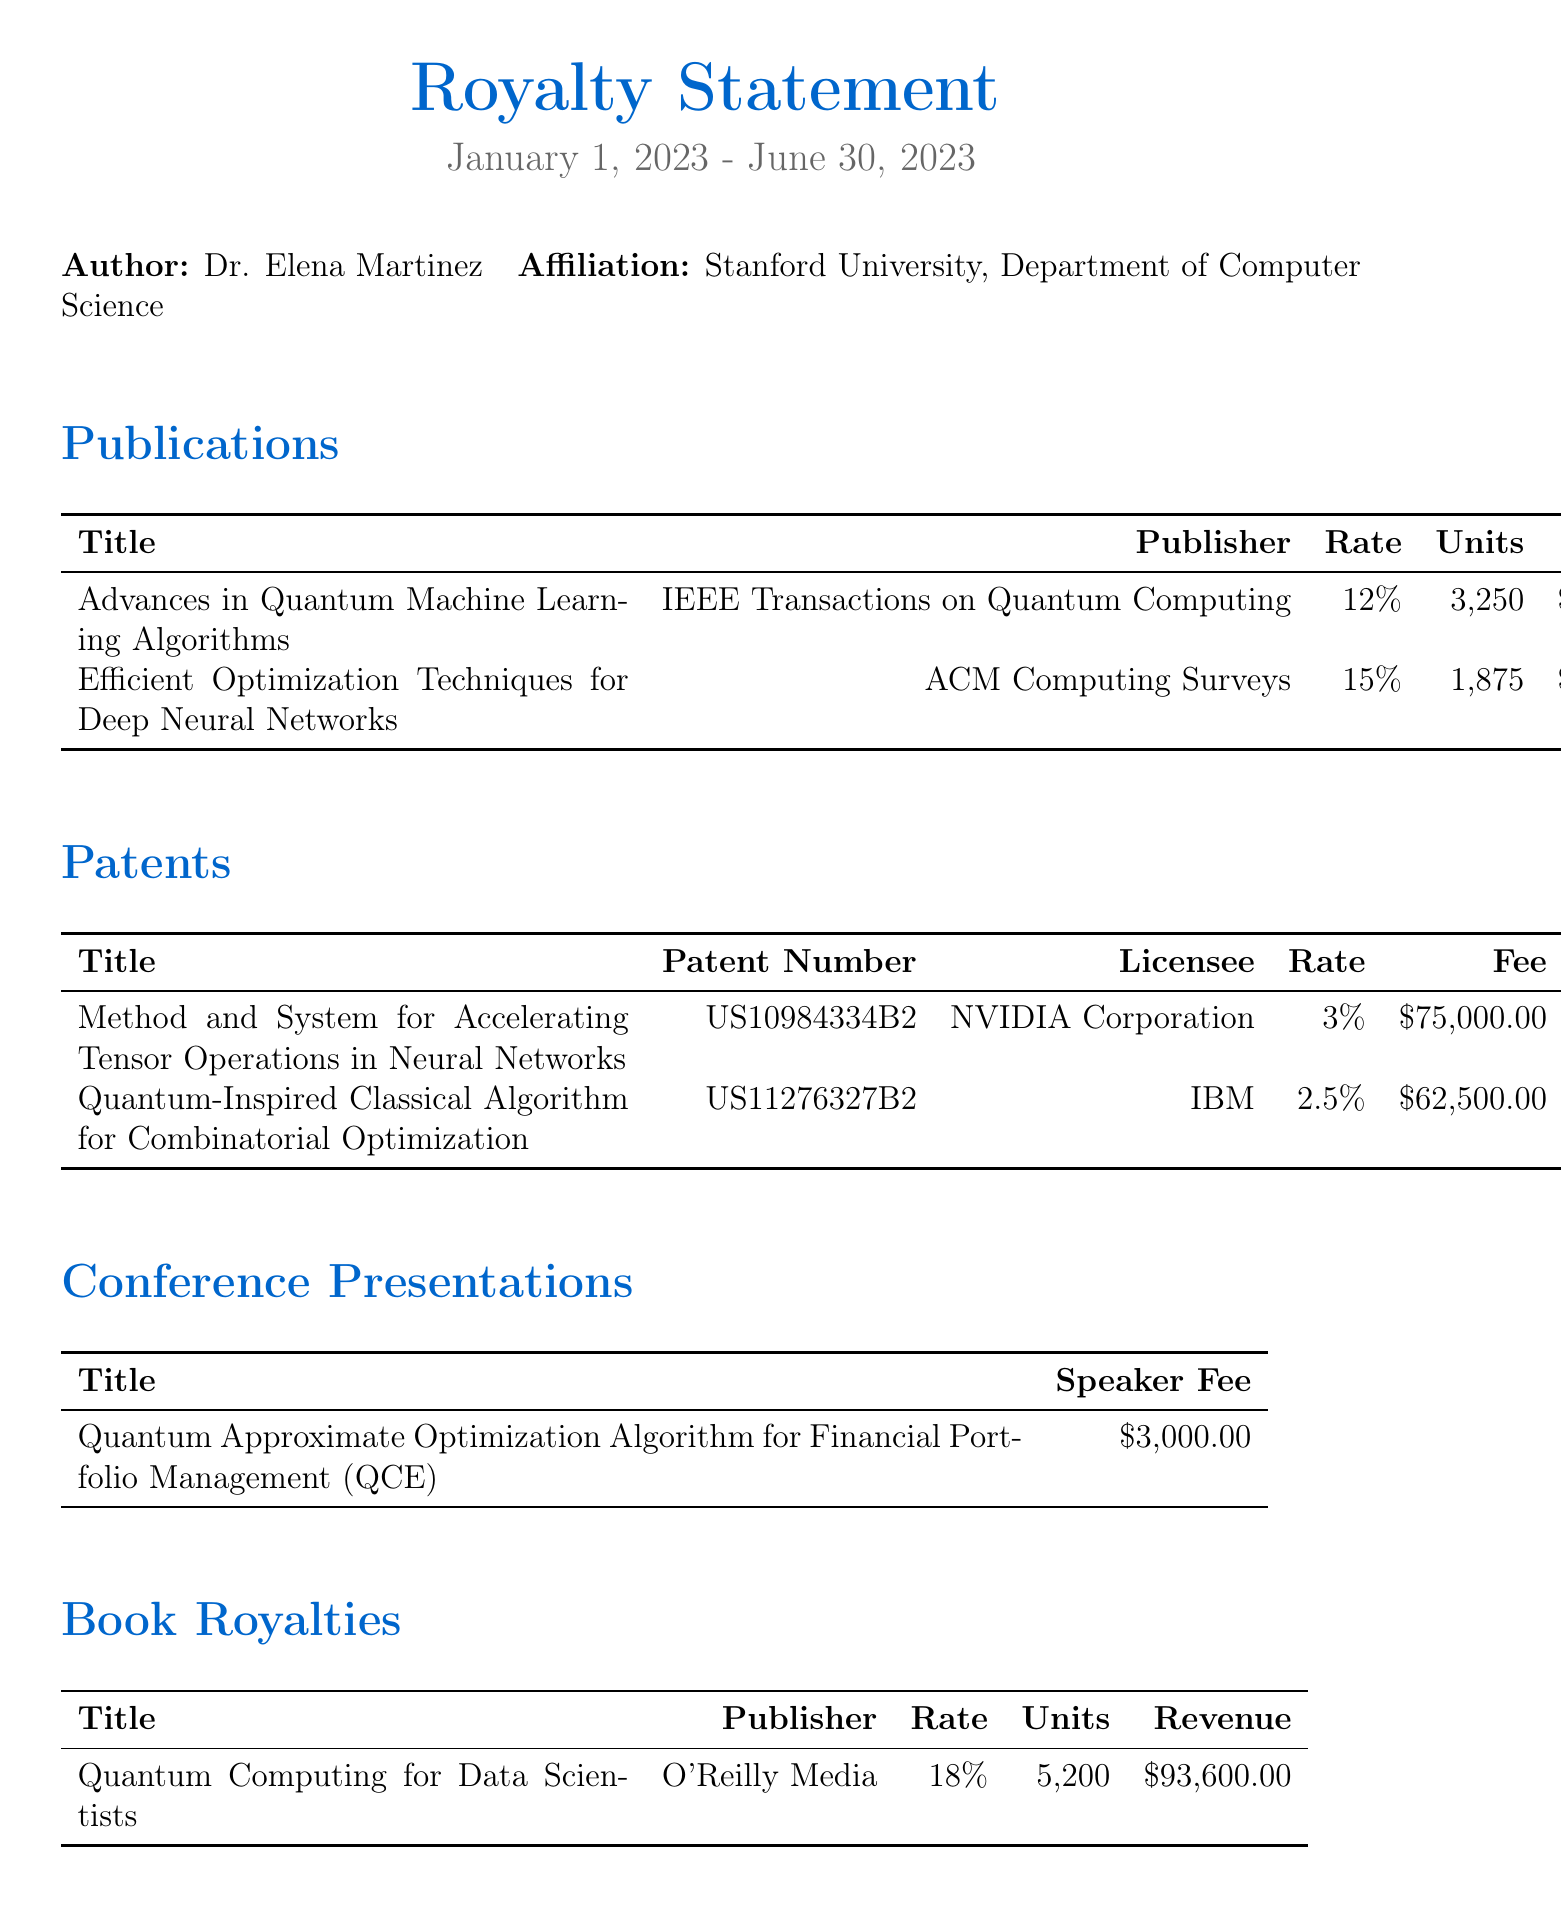what is the author's name? The author's name is provided at the beginning of the document under the Author section.
Answer: Dr. Elena Martinez what is the total earnings reported? The total earnings is stated in the Financial Summary section of the document.
Answer: $311,975.00 how many units of "Advances in Quantum Machine Learning Algorithms" were sold? The number of units sold is listed in the Publications section next to the title of the publication.
Answer: 3,250 what is the royalty rate for the book published by O'Reilly Media? The royalty rate is specified in the Book Royalties section for that particular title.
Answer: 18% who is the licensee for the patent titled "Method and System for Accelerating Tensor Operations in Neural Networks"? The licensee is mentioned under the Patents section next to the patent title.
Answer: NVIDIA Corporation what was the speaker fee for the conference presentation at QCE? The speaker fee is provided in the Conference Presentations section for that specific title.
Answer: $3,000.00 which payment method was used? The payment method is noted in the Payment Details section of the document.
Answer: Direct Deposit what is the tax withholding amount? The tax withholding amount can be found in the Financial Summary section of the document.
Answer: $93,592.50 how long is the statement period? The statement period is noted at the top of the document.
Answer: January 1, 2023 - June 30, 2023 